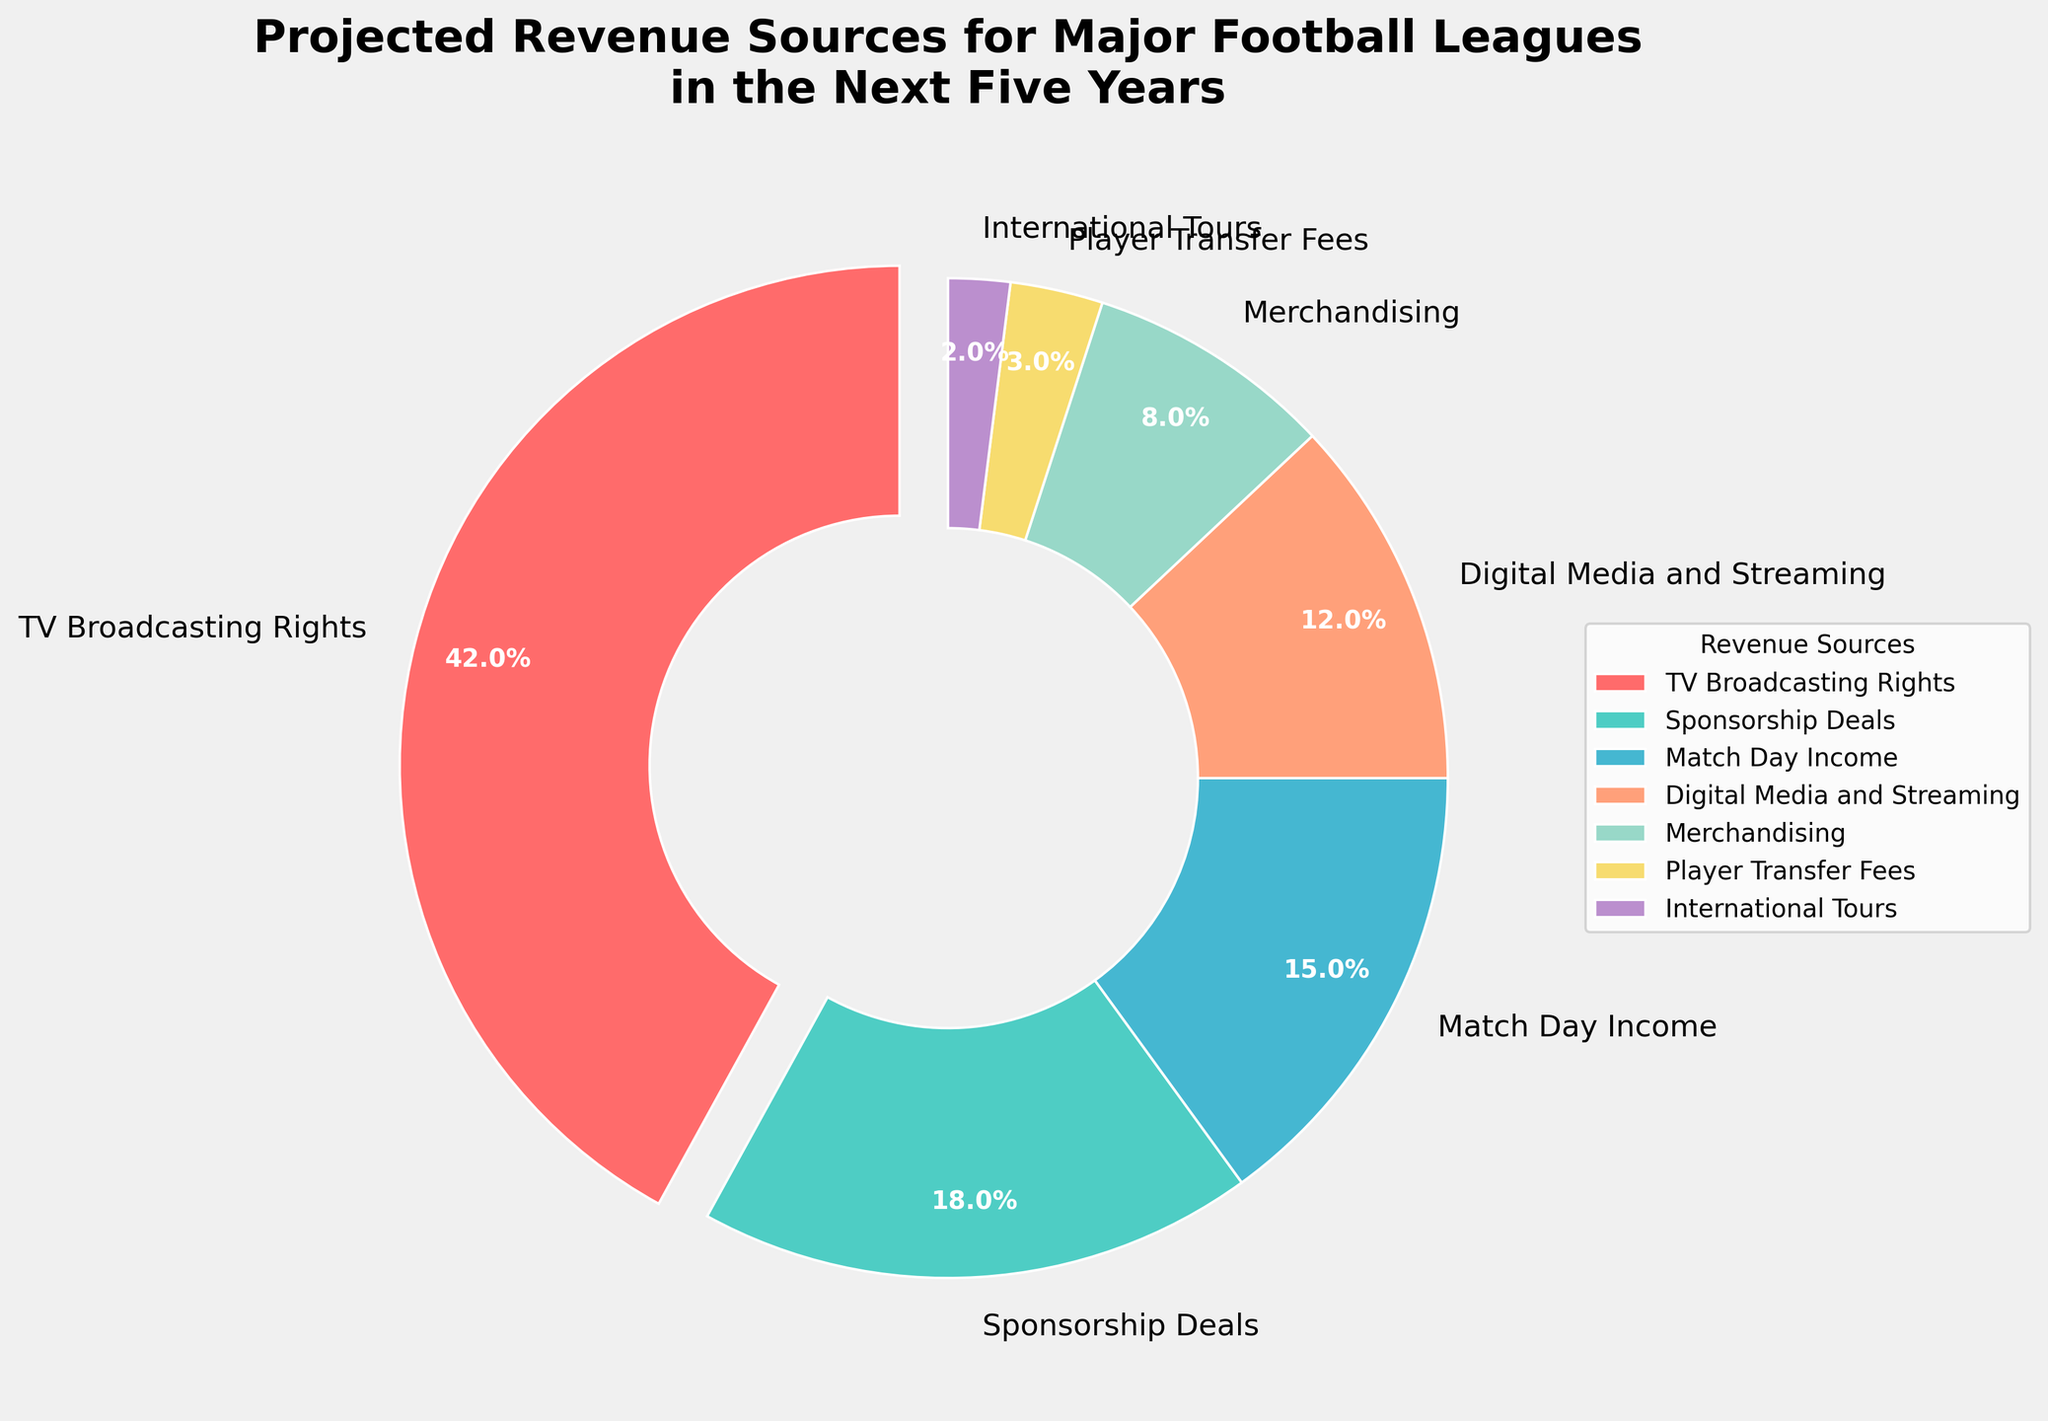What is the source with the highest projected revenue percentage? The pie chart shows that "TV Broadcasting Rights" has the largest wedge, which means it represents the highest percentage. The label on this wedge confirms it is 42%.
Answer: TV Broadcasting Rights Which is larger: the projected revenue from Digital Media and Streaming or from Match Day Income? To compare the two wedges, we look at their sizes. Match Day Income is larger, as it has a projected percentage of 15%, whereas Digital Media and Streaming has a projected percentage of 12%.
Answer: Match Day Income How much greater is the projected revenue from Sponsorship Deals compared to Player Transfer Fees? Sponsorship Deals account for 18% of the revenue, while Player Transfer Fees account for 3%. The difference is calculated by subtracting the smaller percentage from the larger: 18% - 3% = 15%.
Answer: 15% What is the combined projected percentage of revenue from International Tours and Merchandising? The projected percentage for International Tours is 2%, and for Merchandising, it is 8%. Adding these together: 2% + 8% = 10%.
Answer: 10% Among TV Broadcasting Rights, Sponsorship Deals, and Match Day Income, which has the lowest projected revenue percentage? The pie chart indicates that TV Broadcasting Rights is 42%, Sponsorship Deals is 18%, and Match Day Income is 15%. The lowest of these percentages is 15%, corresponding to Match Day Income.
Answer: Match Day Income If the projected revenue from TV Broadcasting Rights were to decrease by 10%, what would the new projected percentage be? The current projected percentage for TV Broadcasting Rights is 42%. A 10% decrease from this value is calculated as follows: 42% - (42% * 0.10) = 42% - 4.2% = 37.8%.
Answer: 37.8% Is the difference between the projected revenue percentages of TV Broadcasting Rights and Digital Media and Streaming greater than the combined percentage of Player Transfer Fees and International Tours? First, find the difference between TV Broadcasting Rights and Digital Media and Streaming: 42% - 12% = 30%. Then, combine the percentages of Player Transfer Fees and International Tours: 3% + 2% = 5%. Since 30% is greater than 5%, the answer is yes.
Answer: Yes What is the sum of the projected revenue percentages for the top three sources? The top three sources by percentage are TV Broadcasting Rights (42%), Sponsorship Deals (18%), and Match Day Income (15%). Adding these together: 42% + 18% + 15% = 75%.
Answer: 75% How do the projected revenue percentages of Sponsorship Deals and Merchandising compare? The pie chart shows Sponsorship Deals at 18% and Merchandising at 8%. Sponsorship Deals has a higher projected revenue percentage than Merchandising.
Answer: Sponsorship Deals What fraction of the total projected revenue does International Tours represent? The projected percentage for International Tours is 2%. To convert this to a fraction of the total revenue, we use the fraction 2/100, which simplifies to 1/50.
Answer: 1/50 